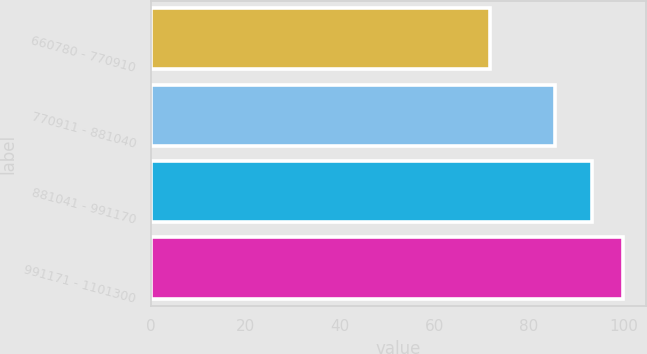<chart> <loc_0><loc_0><loc_500><loc_500><bar_chart><fcel>660780 - 770910<fcel>770911 - 881040<fcel>881041 - 991170<fcel>991171 - 1101300<nl><fcel>71.72<fcel>85.56<fcel>93.39<fcel>99.77<nl></chart> 